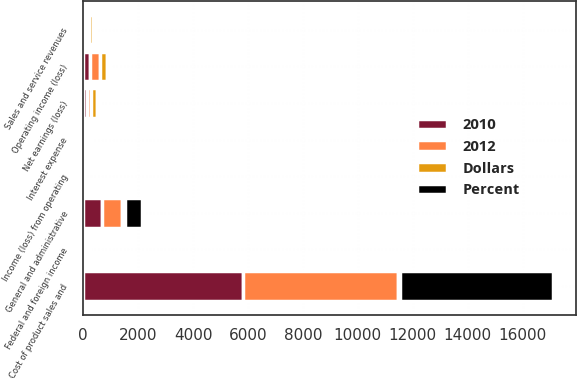Convert chart. <chart><loc_0><loc_0><loc_500><loc_500><stacked_bar_chart><ecel><fcel>Sales and service revenues<fcel>Cost of product sales and<fcel>Income (loss) from operating<fcel>General and administrative<fcel>Operating income (loss)<fcel>Interest expense<fcel>Federal and foreign income<fcel>Net earnings (loss)<nl><fcel>2012<fcel>105<fcel>5629<fcel>18<fcel>739<fcel>358<fcel>117<fcel>95<fcel>146<nl><fcel>Percent<fcel>105<fcel>5571<fcel>20<fcel>634<fcel>100<fcel>104<fcel>96<fcel>100<nl><fcel>2010<fcel>105<fcel>5831<fcel>19<fcel>670<fcel>241<fcel>40<fcel>68<fcel>131<nl><fcel>Dollars<fcel>133<fcel>58<fcel>2<fcel>105<fcel>258<fcel>13<fcel>1<fcel>246<nl></chart> 